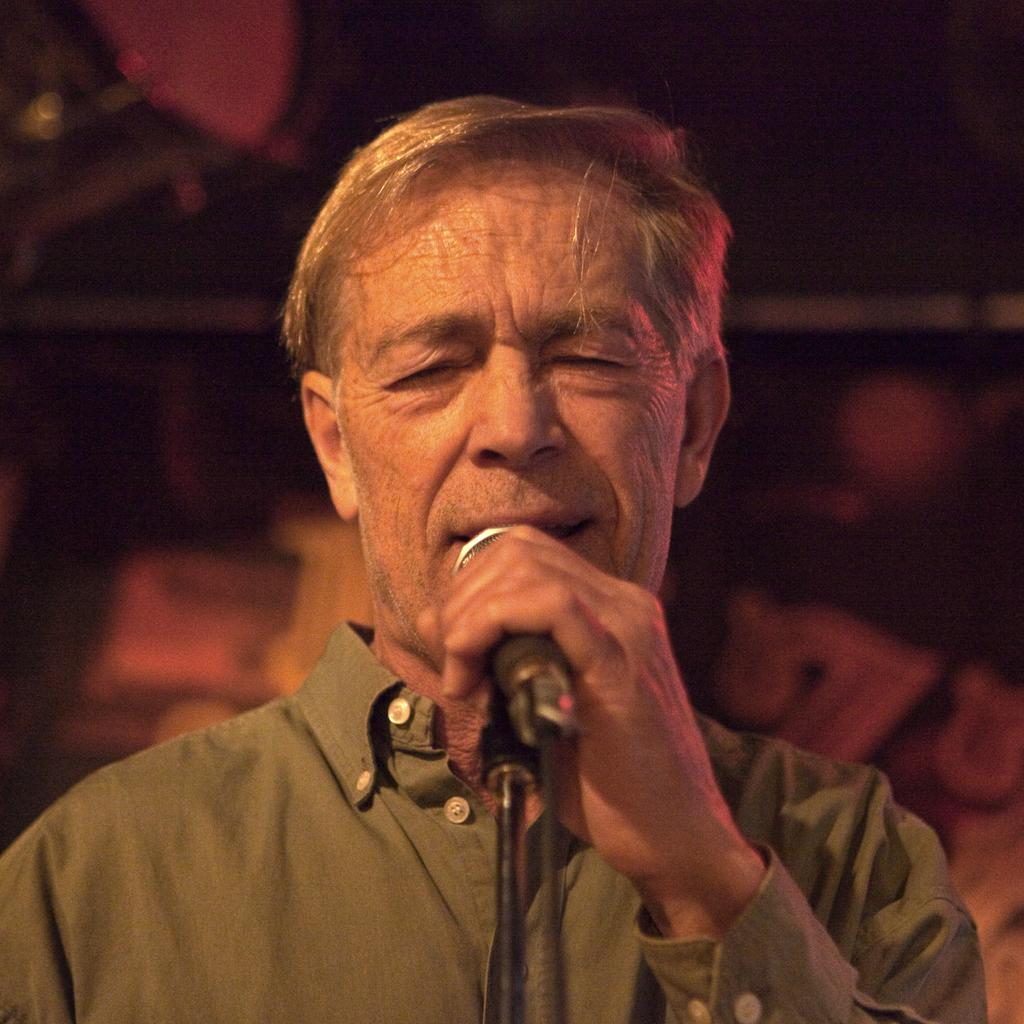Who is the main subject in the image? There is a man in the image. What is the man holding in the image? The man is holding a mic. What is the man doing in the image? The man is singing. What can be observed about the background of the image? The background of the image is dark. How much money is the man holding in the image? The man is not holding any money in the image; he is holding a mic and singing. Is the man made of wax in the image? There is no indication in the image that the man is made of wax; he appears to be a regular person. 